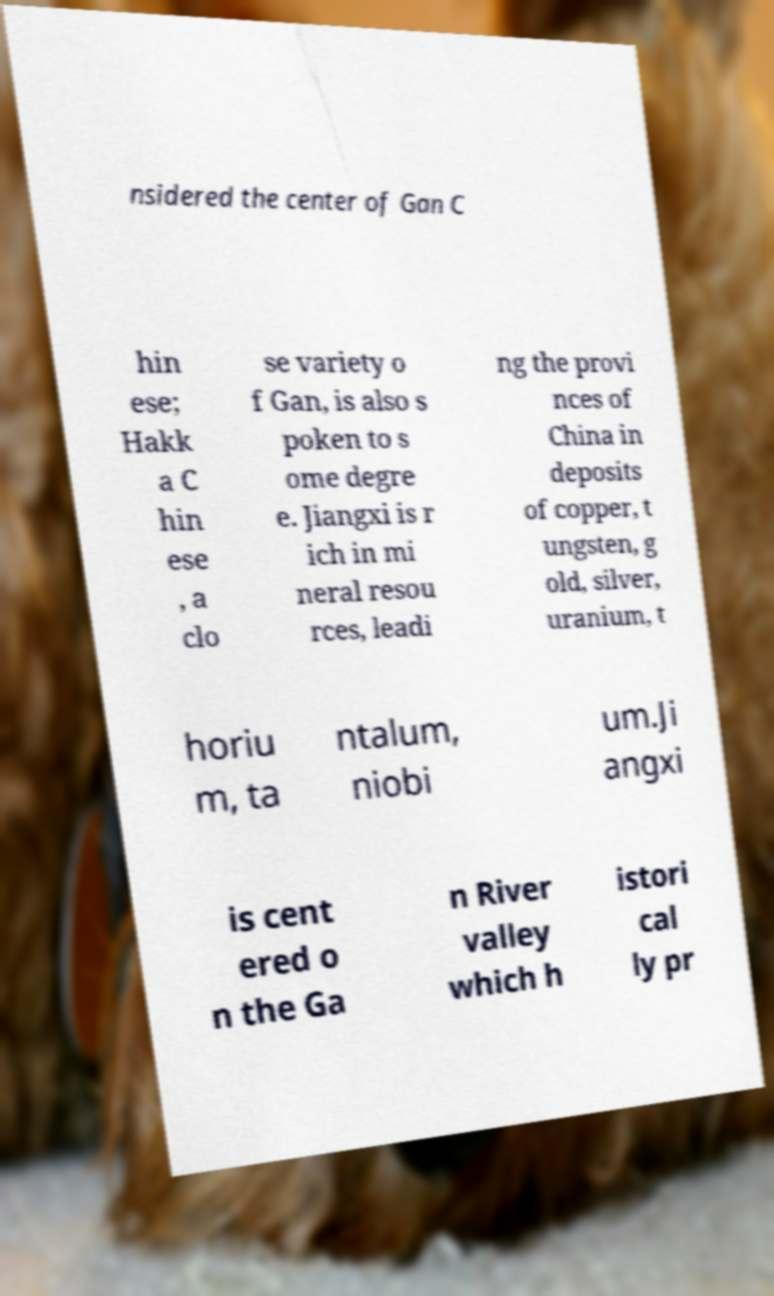Could you assist in decoding the text presented in this image and type it out clearly? nsidered the center of Gan C hin ese; Hakk a C hin ese , a clo se variety o f Gan, is also s poken to s ome degre e. Jiangxi is r ich in mi neral resou rces, leadi ng the provi nces of China in deposits of copper, t ungsten, g old, silver, uranium, t horiu m, ta ntalum, niobi um.Ji angxi is cent ered o n the Ga n River valley which h istori cal ly pr 